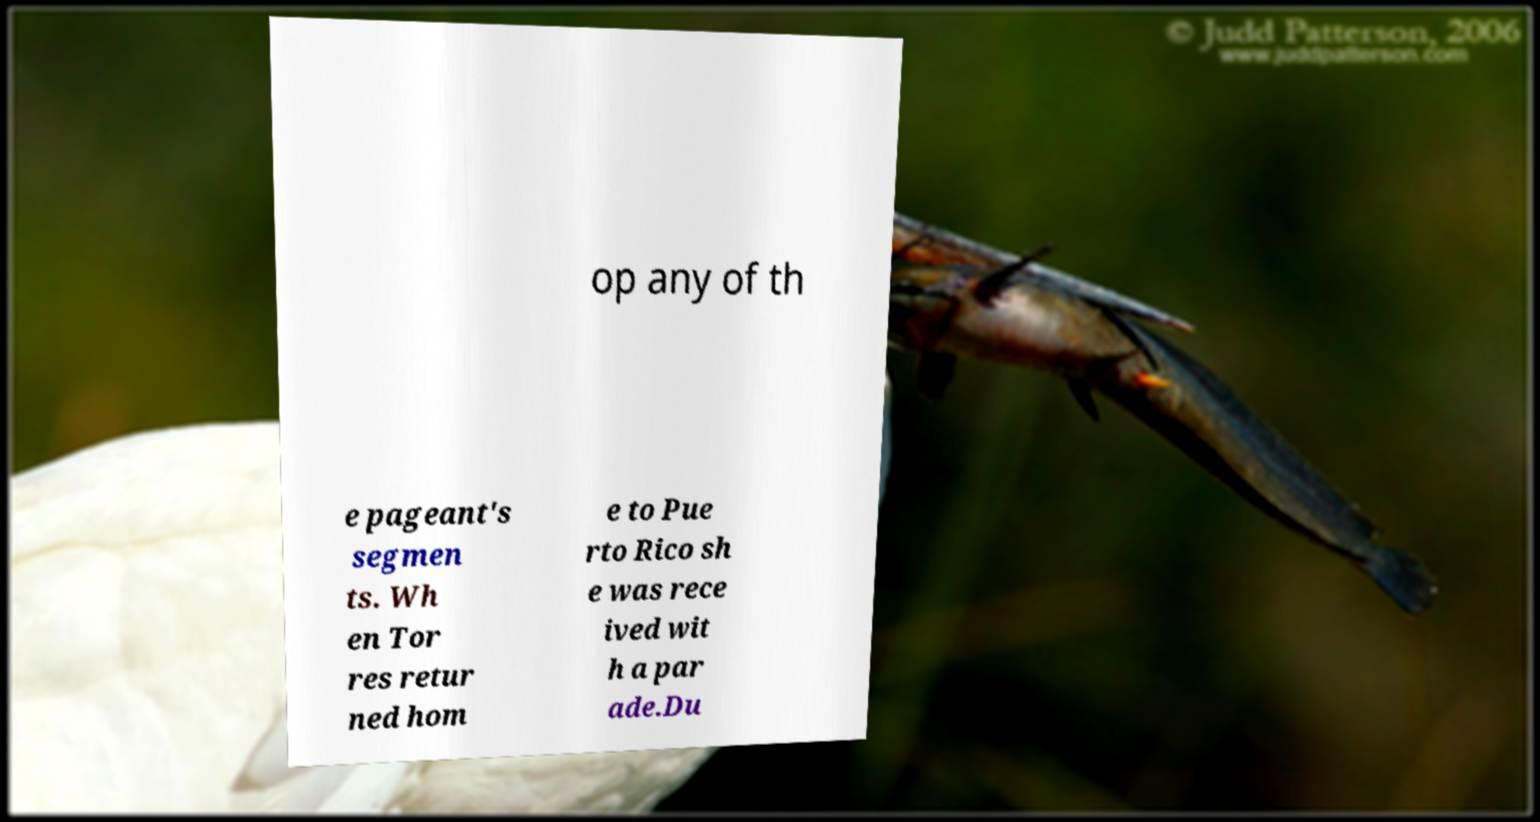I need the written content from this picture converted into text. Can you do that? op any of th e pageant's segmen ts. Wh en Tor res retur ned hom e to Pue rto Rico sh e was rece ived wit h a par ade.Du 